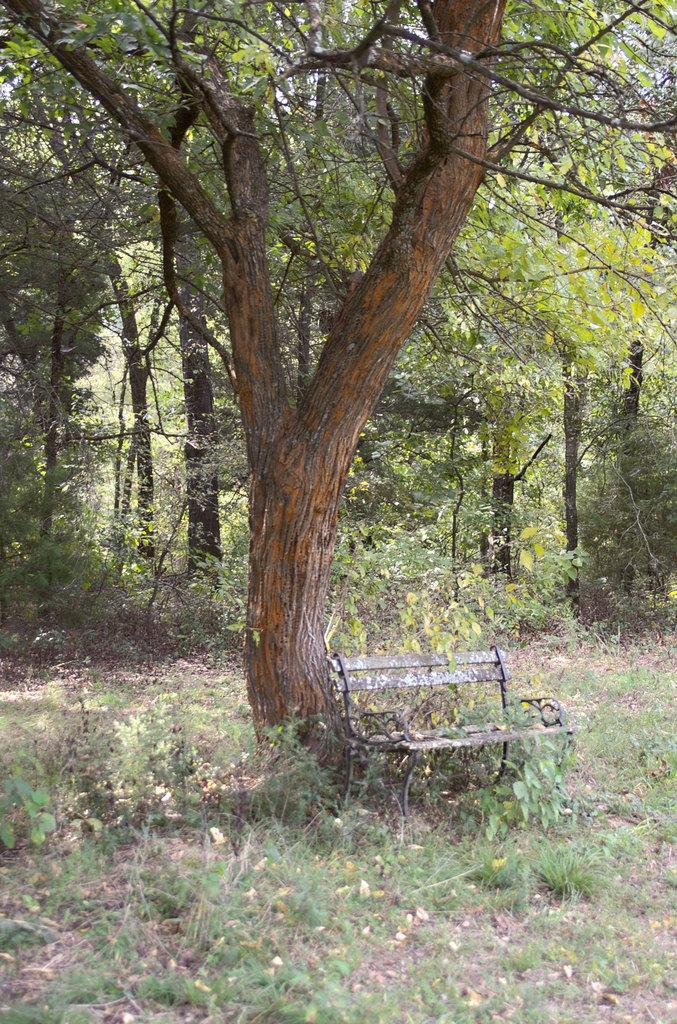What type of vegetation is present on the ground in the front of the image? There is grass on the ground in the front of the image. What object is located in the center of the image? There is an empty bench in the center of the image. What type of plant can be seen in the image? There is a tree in the image. What can be seen in the background of the image? There are trees and plants in the background of the image. Can you tell me how many bears are sitting on the bench in the image? There are no bears present in the image; it features an empty bench. What type of veil is draped over the tree in the image? There is no veil present in the image; it features a tree without any additional coverings. 